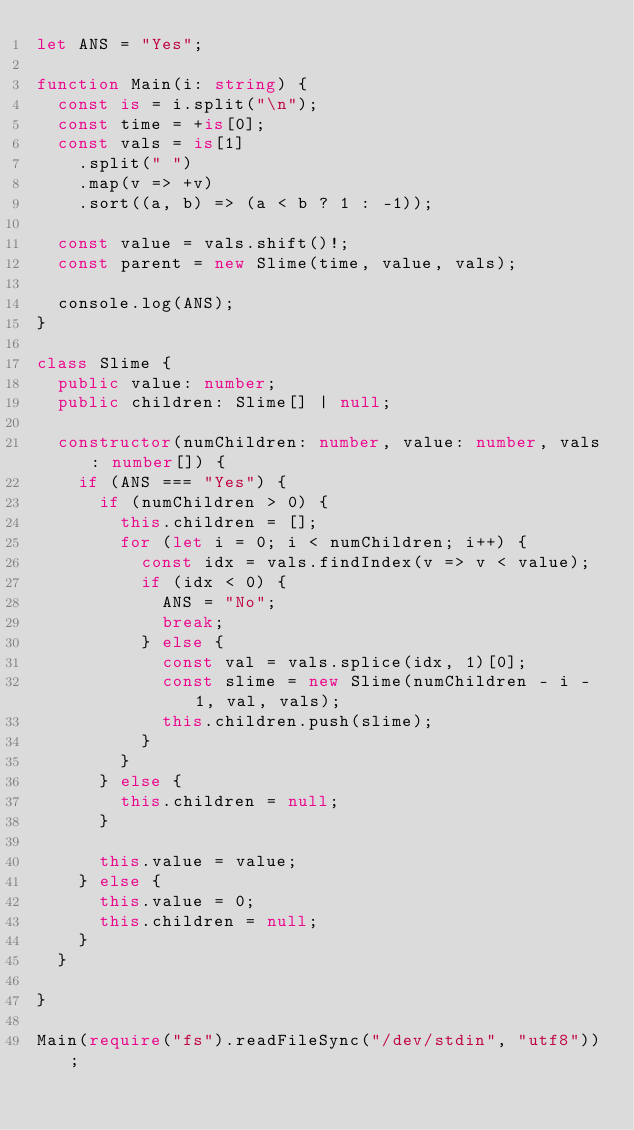<code> <loc_0><loc_0><loc_500><loc_500><_TypeScript_>let ANS = "Yes";

function Main(i: string) {
  const is = i.split("\n");
  const time = +is[0];
  const vals = is[1]
    .split(" ")
    .map(v => +v)
    .sort((a, b) => (a < b ? 1 : -1));

  const value = vals.shift()!;
  const parent = new Slime(time, value, vals);

  console.log(ANS);
}

class Slime {
  public value: number;
  public children: Slime[] | null;

  constructor(numChildren: number, value: number, vals: number[]) {
    if (ANS === "Yes") {
      if (numChildren > 0) {
        this.children = [];
        for (let i = 0; i < numChildren; i++) {
          const idx = vals.findIndex(v => v < value);
          if (idx < 0) {
            ANS = "No";
            break;
          } else {
            const val = vals.splice(idx, 1)[0];
            const slime = new Slime(numChildren - i - 1, val, vals);
            this.children.push(slime);
          }
        }
      } else {
        this.children = null;
      }

      this.value = value;
    } else {
      this.value = 0;
      this.children = null;
    }
  }

}

Main(require("fs").readFileSync("/dev/stdin", "utf8"));
</code> 